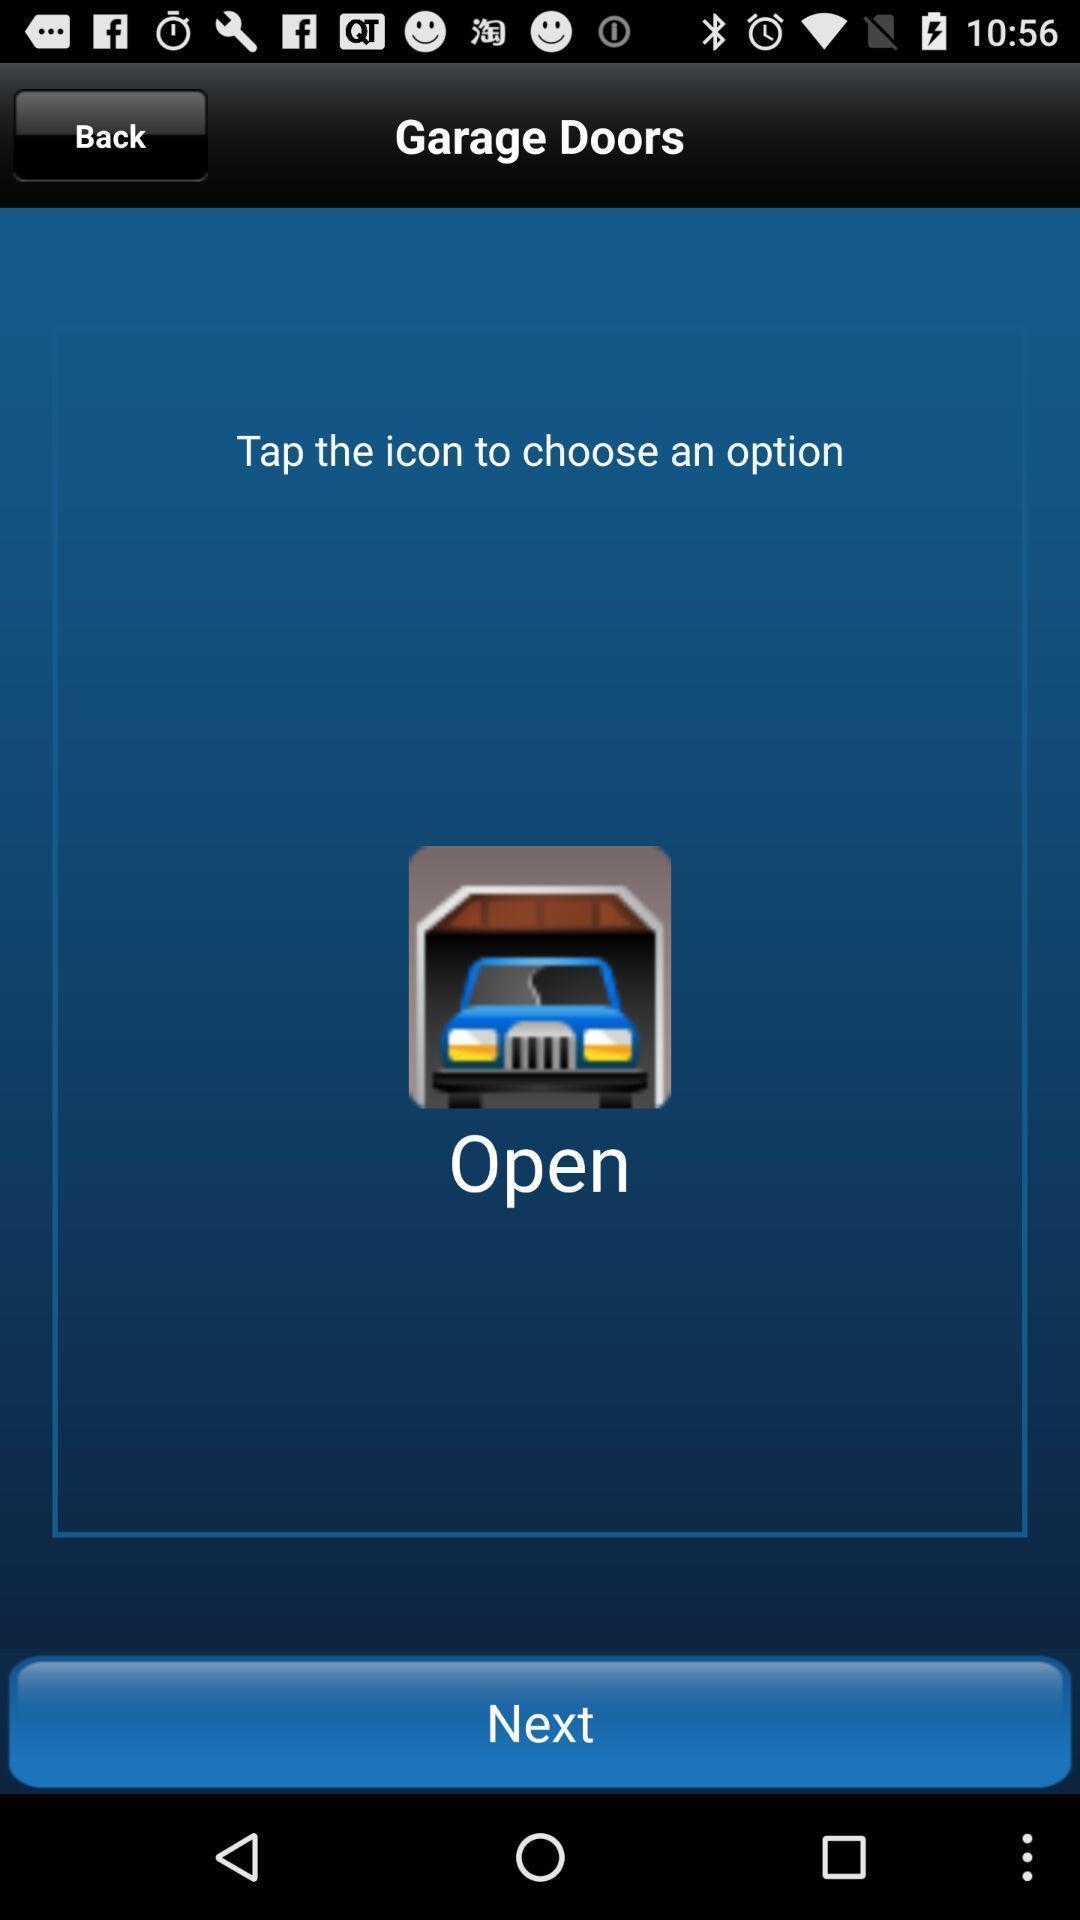Describe the key features of this screenshot. Screen shows next option to continue with a remote app. 